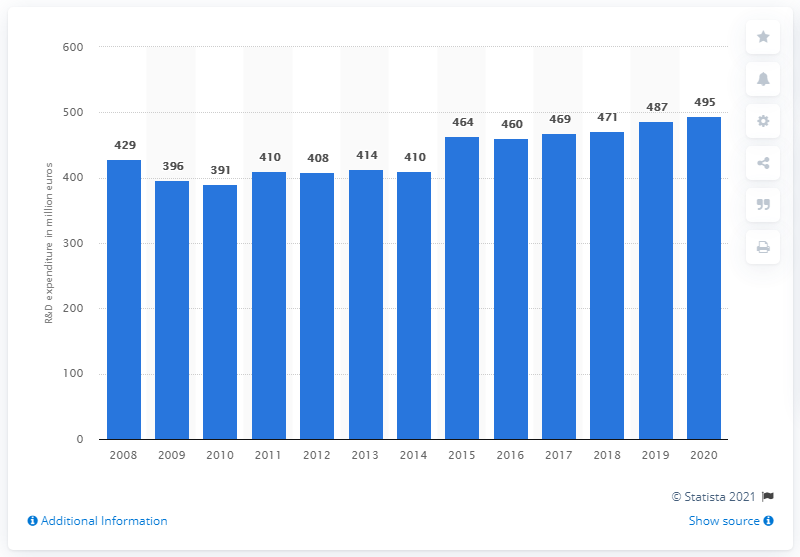Specify some key components in this picture. Henkel spent 495 million euros on research and development in 2020. 